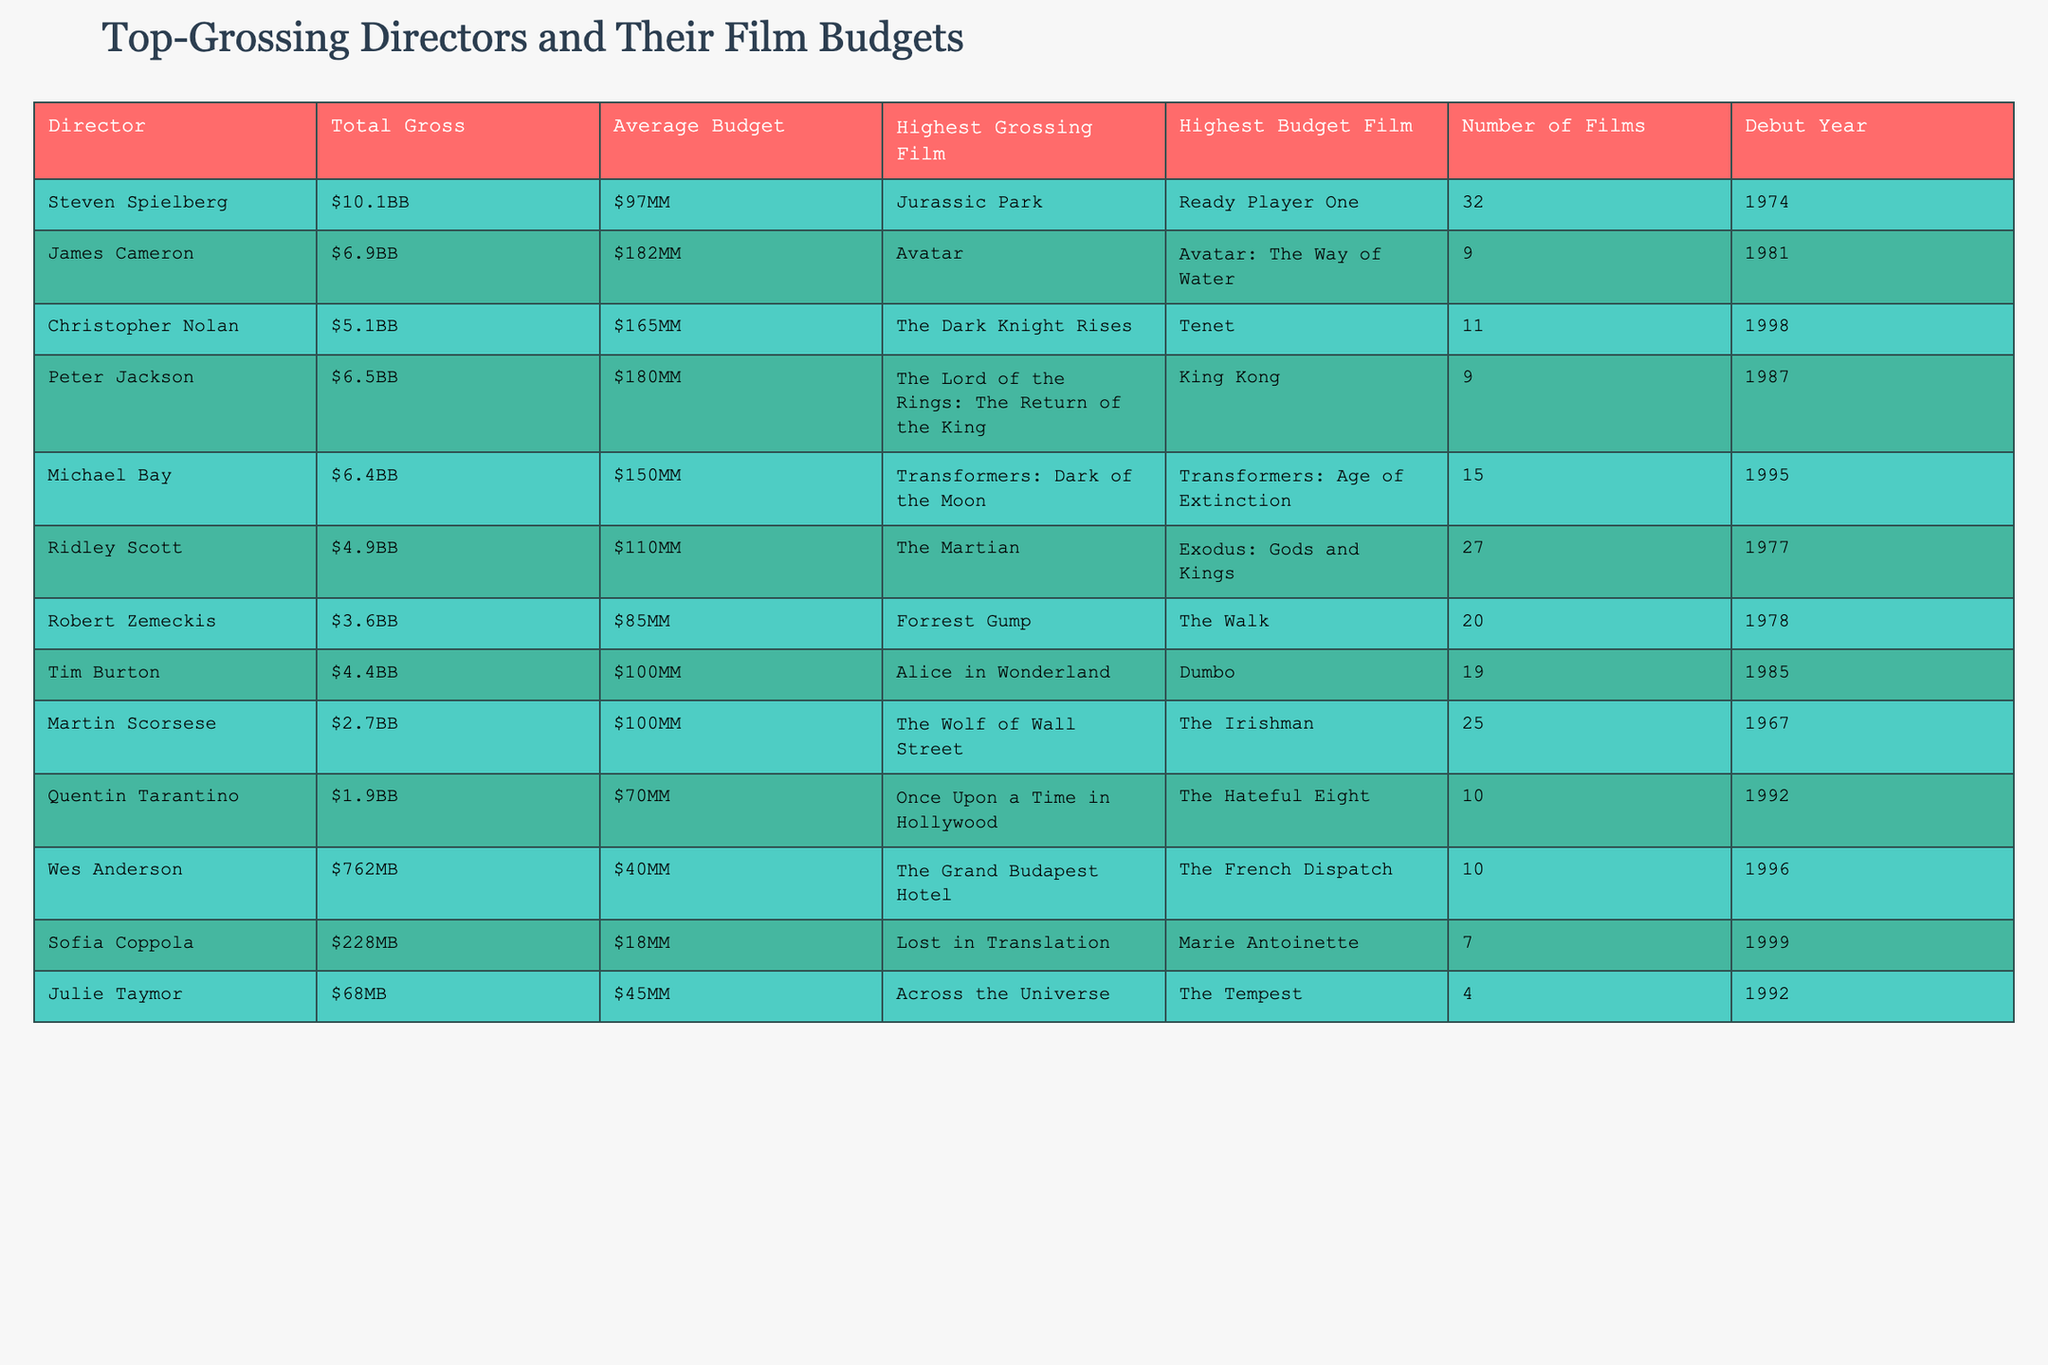What is the total gross of Steven Spielberg's films? According to the table, Steven Spielberg's total gross is listed as 10.1B.
Answer: 10.1B Which director has the highest average budget? James Cameron has the highest average budget of 182M, compared to others listed in the table.
Answer: 182M How many films has Michael Bay directed? The table indicates that Michael Bay has directed a total of 15 films.
Answer: 15 What is the highest grossing film of Christopher Nolan? The table specifies that Christopher Nolan's highest grossing film is The Dark Knight Rises.
Answer: The Dark Knight Rises Is Sofia Coppola's highest grossing film greater than 300 million? According to the table, Sofia Coppola's highest grossing film, Lost in Translation, has a total gross of 228M, which is less than 300M.
Answer: No Calculate the difference in total gross between Peter Jackson and Ridley Scott. Peter Jackson's total gross is 6.5B and Ridley Scott's is 4.9B. The difference is 6.5B - 4.9B = 1.6B.
Answer: 1.6B Which director has the lowest average budget and what is that budget? The table shows that Wes Anderson has the lowest average budget of 40M.
Answer: 40M Among the top-grossing directors, how many films were directed after the year 2000? The directors with debut years after 2000 are Christopher Nolan and Sofia Coppola. Nolan has 11 films and Coppola has 7 films, totaling 18 films directed after 2000.
Answer: 18 What is the ratio of the highest budget film of James Cameron to that of Tim Burton? James Cameron's highest budget film is Avatar: The Way of Water (budget 182M) and Tim Burton's is Dumbo (budget 100M). The ratio is 182M:100M, which simplifies to 1.82:1.
Answer: 1.82:1 Which director has the most films and what is their total gross? Ridley Scott has directed the most films (27) and has a total gross of 4.9B.
Answer: 4.9B 